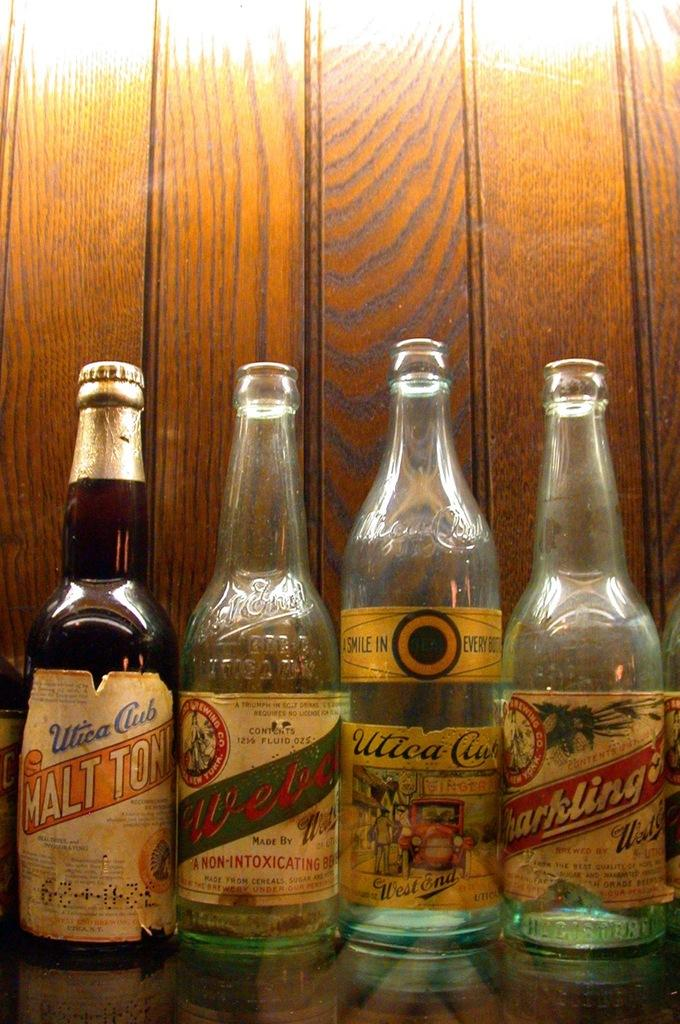Provide a one-sentence caption for the provided image. Several bottles are lined up including some of the brand Utica Club. 